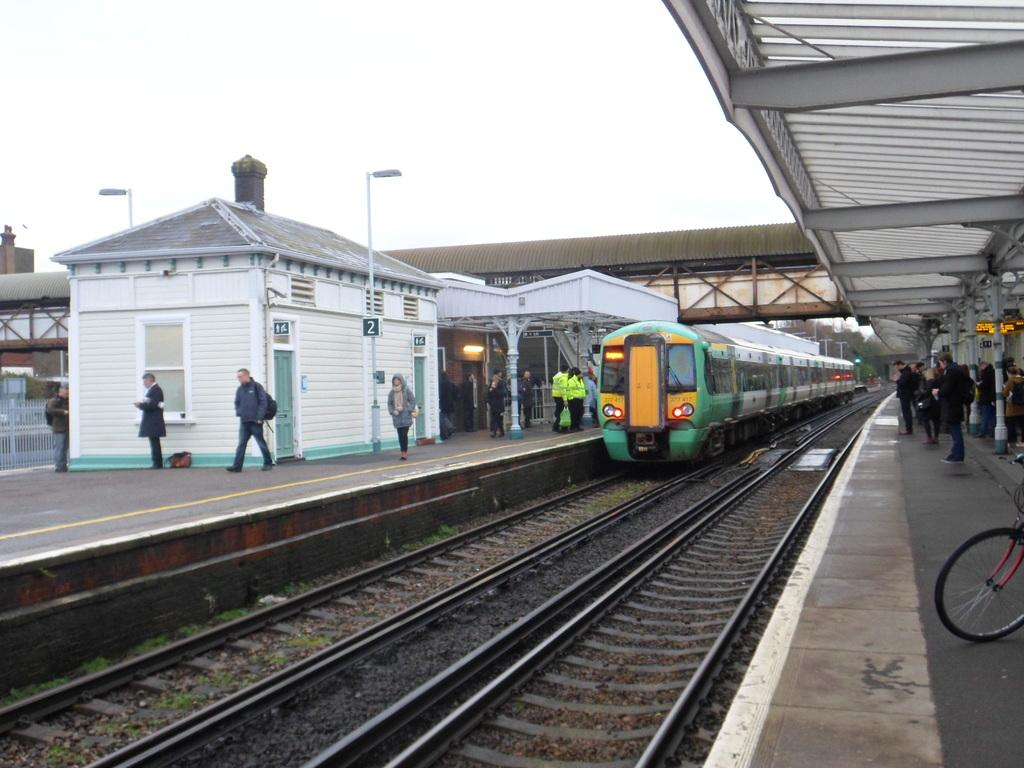What is the main subject of the image? The main subject of the image is a train on a railway track. What else can be seen in the image besides the train? There are people on a platform, sheds, poles, a bridge, a fence, trees, and some objects in the image. Can you describe the setting of the image? The image shows a railway track with a train, surrounded by various structures and natural elements, such as sheds, poles, a bridge, a fence, trees, and the sky visible in the background. What type of letter is being delivered by the train in the image? There is no indication of a letter being delivered by the train in the image. Can you see any shoes on the people waiting on the platform in the image? The image does not show the shoes of the people on the platform, so it cannot be determined from the image. 